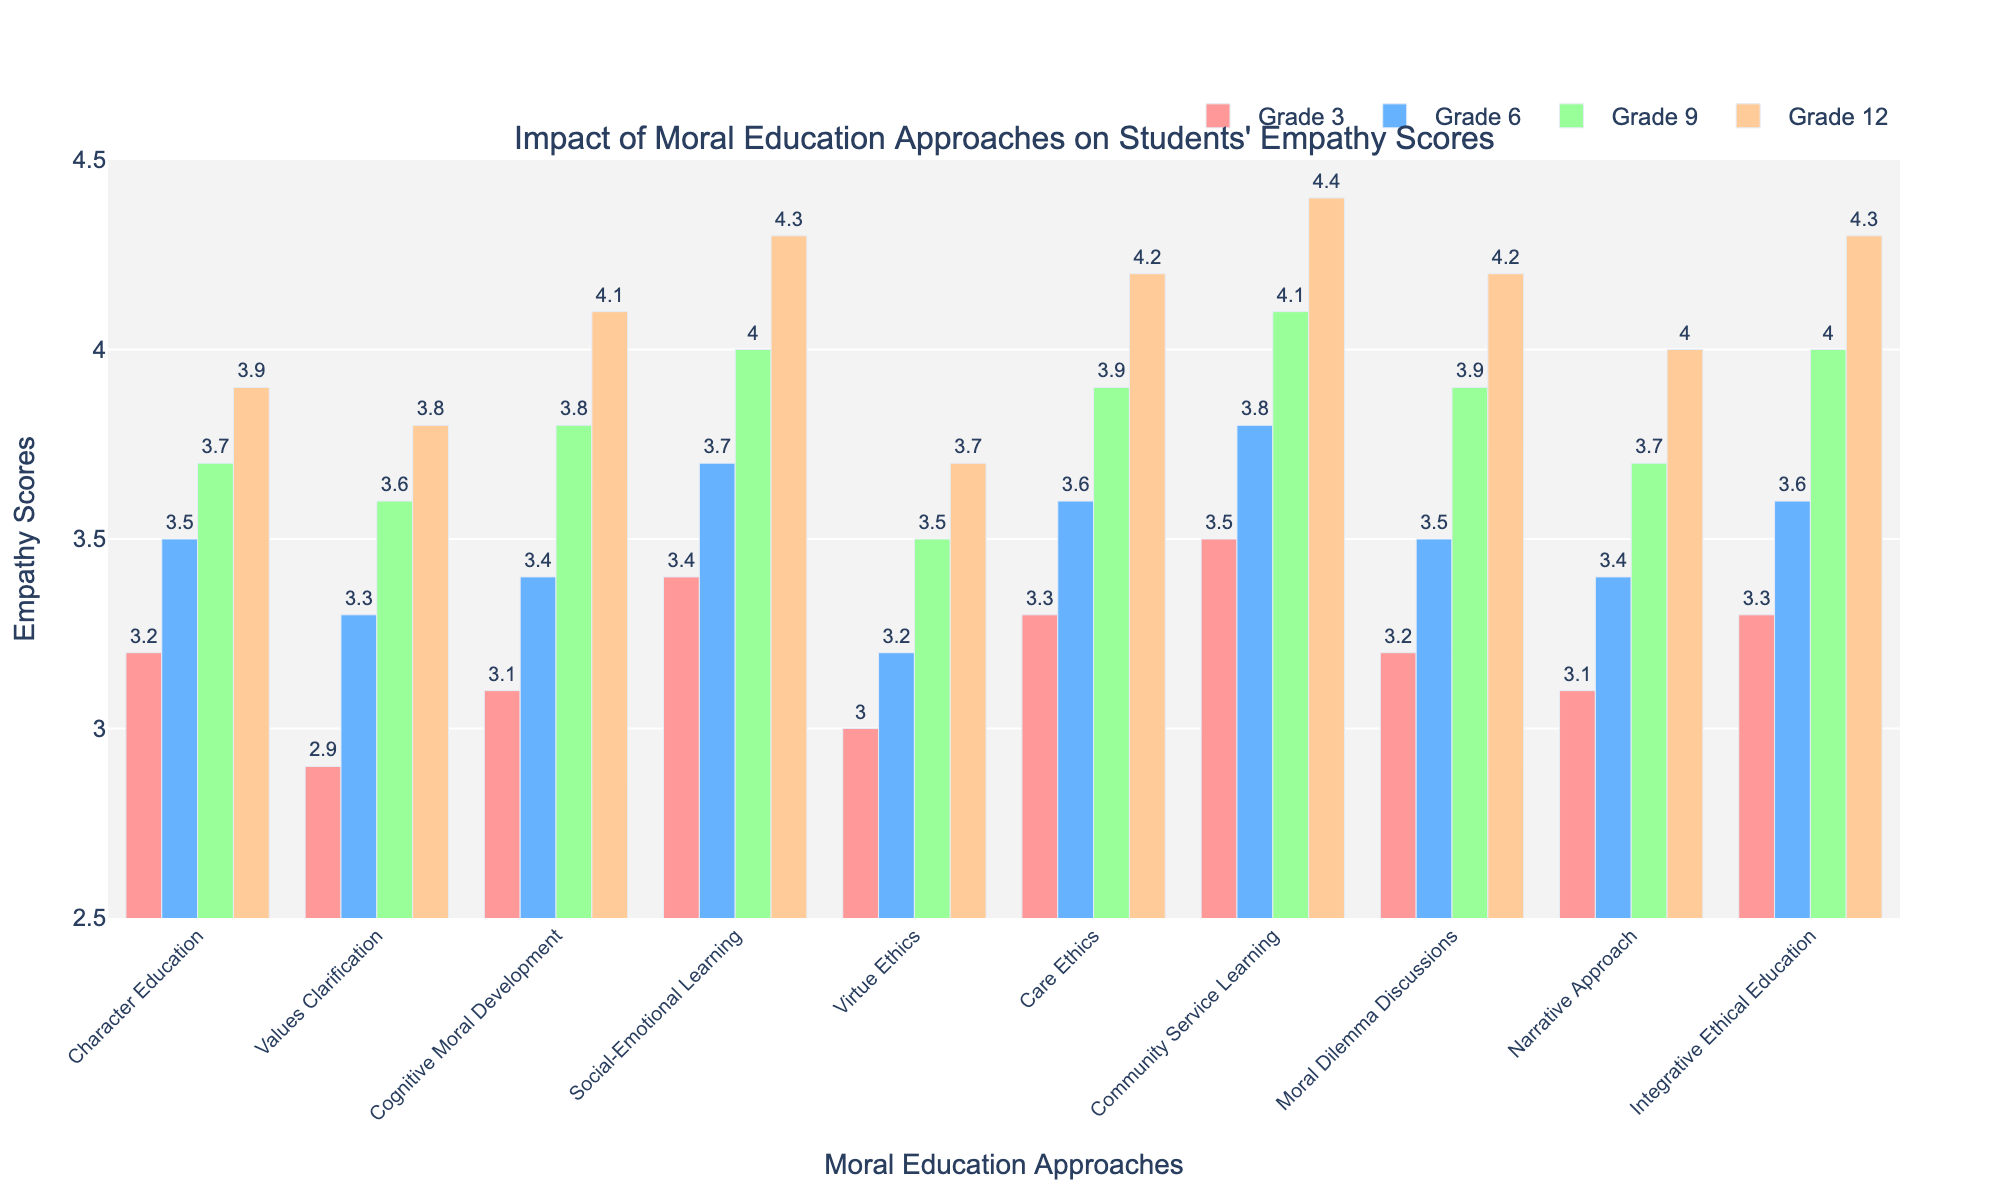What is the highest empathy score observed in Grade 12? Look at the values of empathy scores for Grade 12 across all moral education approaches. The highest value is 4.4 for "Community Service Learning".
Answer: 4.4 Which approach has the lowest empathy score in Grade 9? Look at the values of empathy scores for Grade 9 across all moral education approaches. The lowest value is 3.5 for "Virtue Ethics".
Answer: Virtue Ethics How does the empathy score of "Care Ethics" in Grade 12 compare with "Character Education" in Grade 9? Compare empathy scores of "Care Ethics" in Grade 12 (4.2) with "Character Education" in Grade 9 (3.7). 4.2 is greater than 3.7.
Answer: Care Ethics in Grade 12 is higher Which two approaches have the same empathy score in Grade 6, and what is this value? Look at the empathy scores for Grade 6 and identify any two approaches that share the same score. "Character Education" and "Moral Dilemma Discussions" both have a score of 3.5.
Answer: Character Education and Moral Dilemma Discussions; 3.5 What is the average empathy score for "Integrative Ethical Education" across all grade levels? Calculate the average by summing empathy scores for "Integrative Ethical Education" across Grade 3, Grade 6, Grade 9, and Grade 12, then divide by 4: (3.3 + 3.6 + 4.0 + 4.3) / 4 = 3.8
Answer: 3.8 